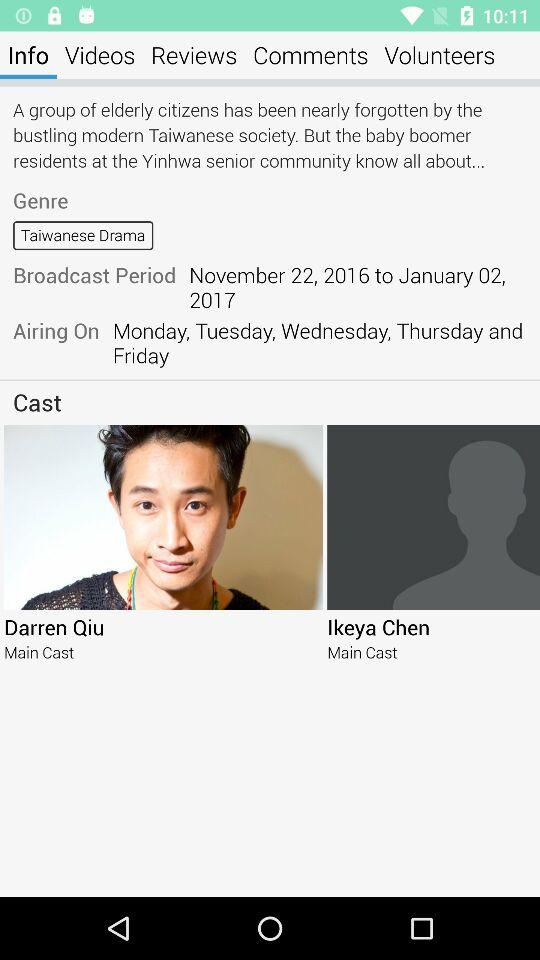How many main cast members are there?
Answer the question using a single word or phrase. 2 